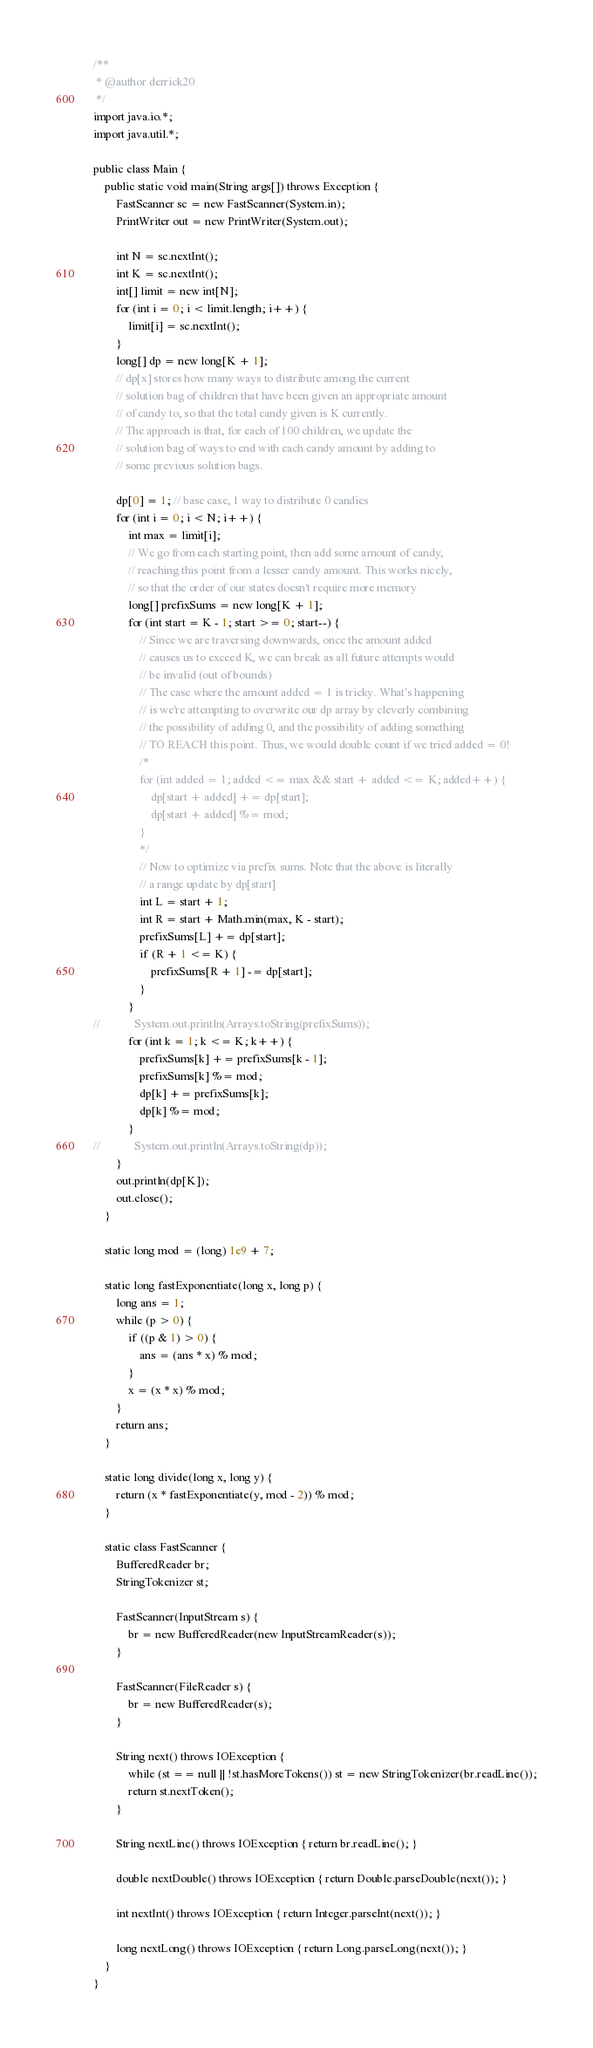Convert code to text. <code><loc_0><loc_0><loc_500><loc_500><_Java_>/**
 * @author derrick20
 */
import java.io.*;
import java.util.*;

public class Main {
    public static void main(String args[]) throws Exception {
        FastScanner sc = new FastScanner(System.in);
        PrintWriter out = new PrintWriter(System.out);

        int N = sc.nextInt();
        int K = sc.nextInt();
        int[] limit = new int[N];
        for (int i = 0; i < limit.length; i++) {
            limit[i] = sc.nextInt();
        }
        long[] dp = new long[K + 1];
        // dp[x] stores how many ways to distribute among the current
        // solution bag of children that have been given an appropriate amount
        // of candy to, so that the total candy given is K currently.
        // The approach is that, for each of 100 children, we update the
        // solution bag of ways to end with each candy amount by adding to
        // some previous solution bags.

        dp[0] = 1; // base case, 1 way to distribute 0 candies
        for (int i = 0; i < N; i++) {
            int max = limit[i];
            // We go from each starting point, then add some amount of candy,
            // reaching this point from a lesser candy amount. This works nicely,
            // so that the order of our states doesn't require more memory
            long[] prefixSums = new long[K + 1];
            for (int start = K - 1; start >= 0; start--) {
                // Since we are traversing downwards, once the amount added
                // causes us to exceed K, we can break as all future attempts would
                // be invalid (out of bounds)
                // The case where the amount added = 1 is tricky. What's happening
                // is we're attempting to overwrite our dp array by cleverly combining
                // the possibility of adding 0, and the possibility of adding something
                // TO REACH this point. Thus, we would double count if we tried added = 0!
                /*
                for (int added = 1; added <= max && start + added <= K; added++) {
                    dp[start + added] += dp[start];
                    dp[start + added] %= mod;
                }
                */
                // Now to optimize via prefix sums. Note that the above is literally
                // a range update by dp[start]
                int L = start + 1;
                int R = start + Math.min(max, K - start);
                prefixSums[L] += dp[start];
                if (R + 1 <= K) {
                    prefixSums[R + 1] -= dp[start];
                }
            }
//            System.out.println(Arrays.toString(prefixSums));
            for (int k = 1; k <= K; k++) {
                prefixSums[k] += prefixSums[k - 1];
                prefixSums[k] %= mod;
                dp[k] += prefixSums[k];
                dp[k] %= mod;
            }
//            System.out.println(Arrays.toString(dp));
        }
        out.println(dp[K]);
        out.close();
    }

    static long mod = (long) 1e9 + 7;

    static long fastExponentiate(long x, long p) {
        long ans = 1;
        while (p > 0) {
            if ((p & 1) > 0) {
                ans = (ans * x) % mod;
            }
            x = (x * x) % mod;
        }
        return ans;
    }

    static long divide(long x, long y) {
        return (x * fastExponentiate(y, mod - 2)) % mod;
    }

    static class FastScanner {
        BufferedReader br;
        StringTokenizer st;

        FastScanner(InputStream s) {
            br = new BufferedReader(new InputStreamReader(s));
        }

        FastScanner(FileReader s) {
            br = new BufferedReader(s);
        }

        String next() throws IOException {
            while (st == null || !st.hasMoreTokens()) st = new StringTokenizer(br.readLine());
            return st.nextToken();
        }

        String nextLine() throws IOException { return br.readLine(); }

        double nextDouble() throws IOException { return Double.parseDouble(next()); }

        int nextInt() throws IOException { return Integer.parseInt(next()); }

        long nextLong() throws IOException { return Long.parseLong(next()); }
    }
}</code> 